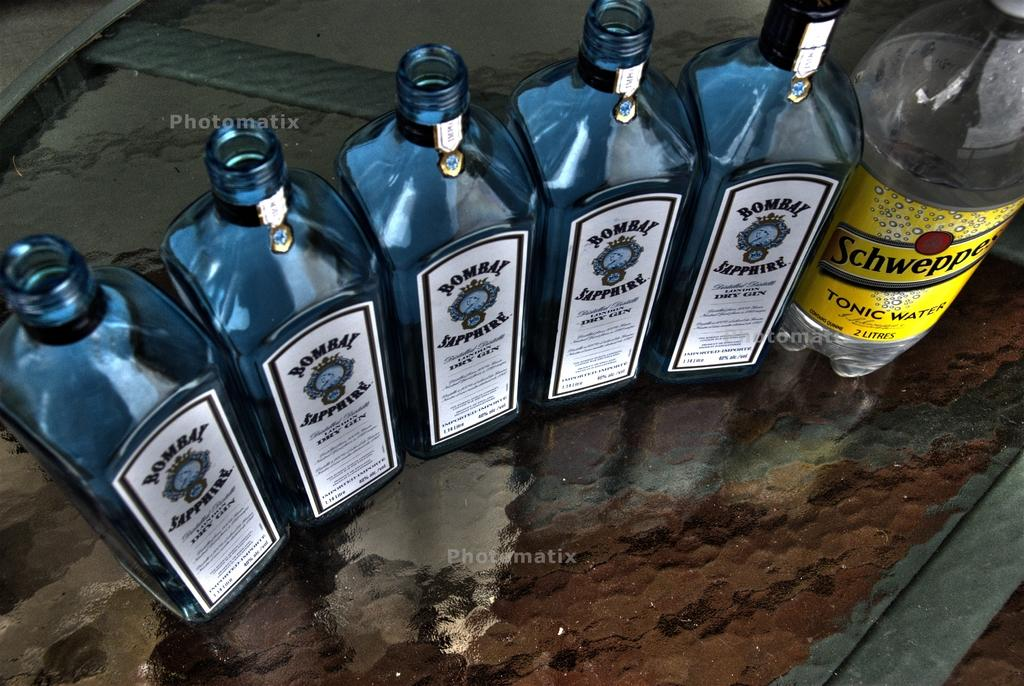<image>
Present a compact description of the photo's key features. Five bottles of Bombay Sapphire sit next to a bottle of tonic water. 